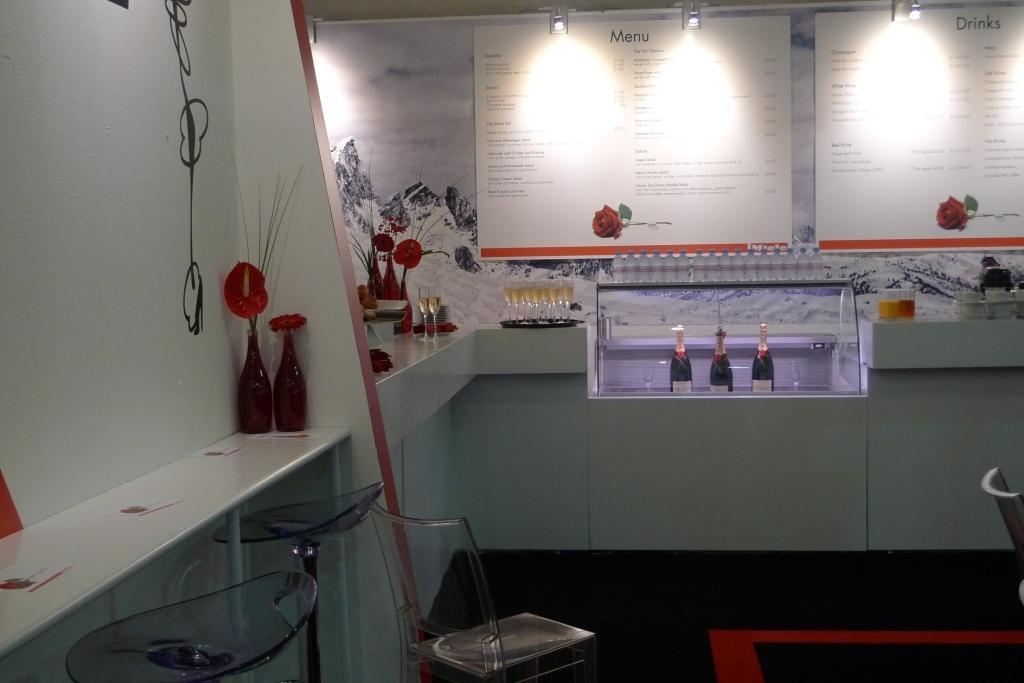Could you give a brief overview of what you see in this image? In this picture we can observe chairs in front of this white color desk. There are two red color flower vases placed on this desk. We can observe three bottles placed in this shelf. There are two white color boards fixed here. We can observe lights. In the background there is a wall. 